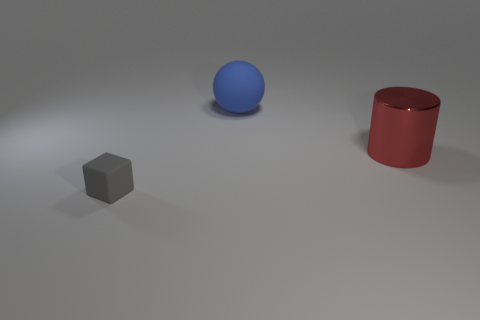The object that is left of the metal object and behind the small rubber object is what color? blue 